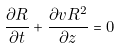<formula> <loc_0><loc_0><loc_500><loc_500>\frac { \partial R } { \partial t } + \frac { \partial v R ^ { 2 } } { \partial z } = 0</formula> 